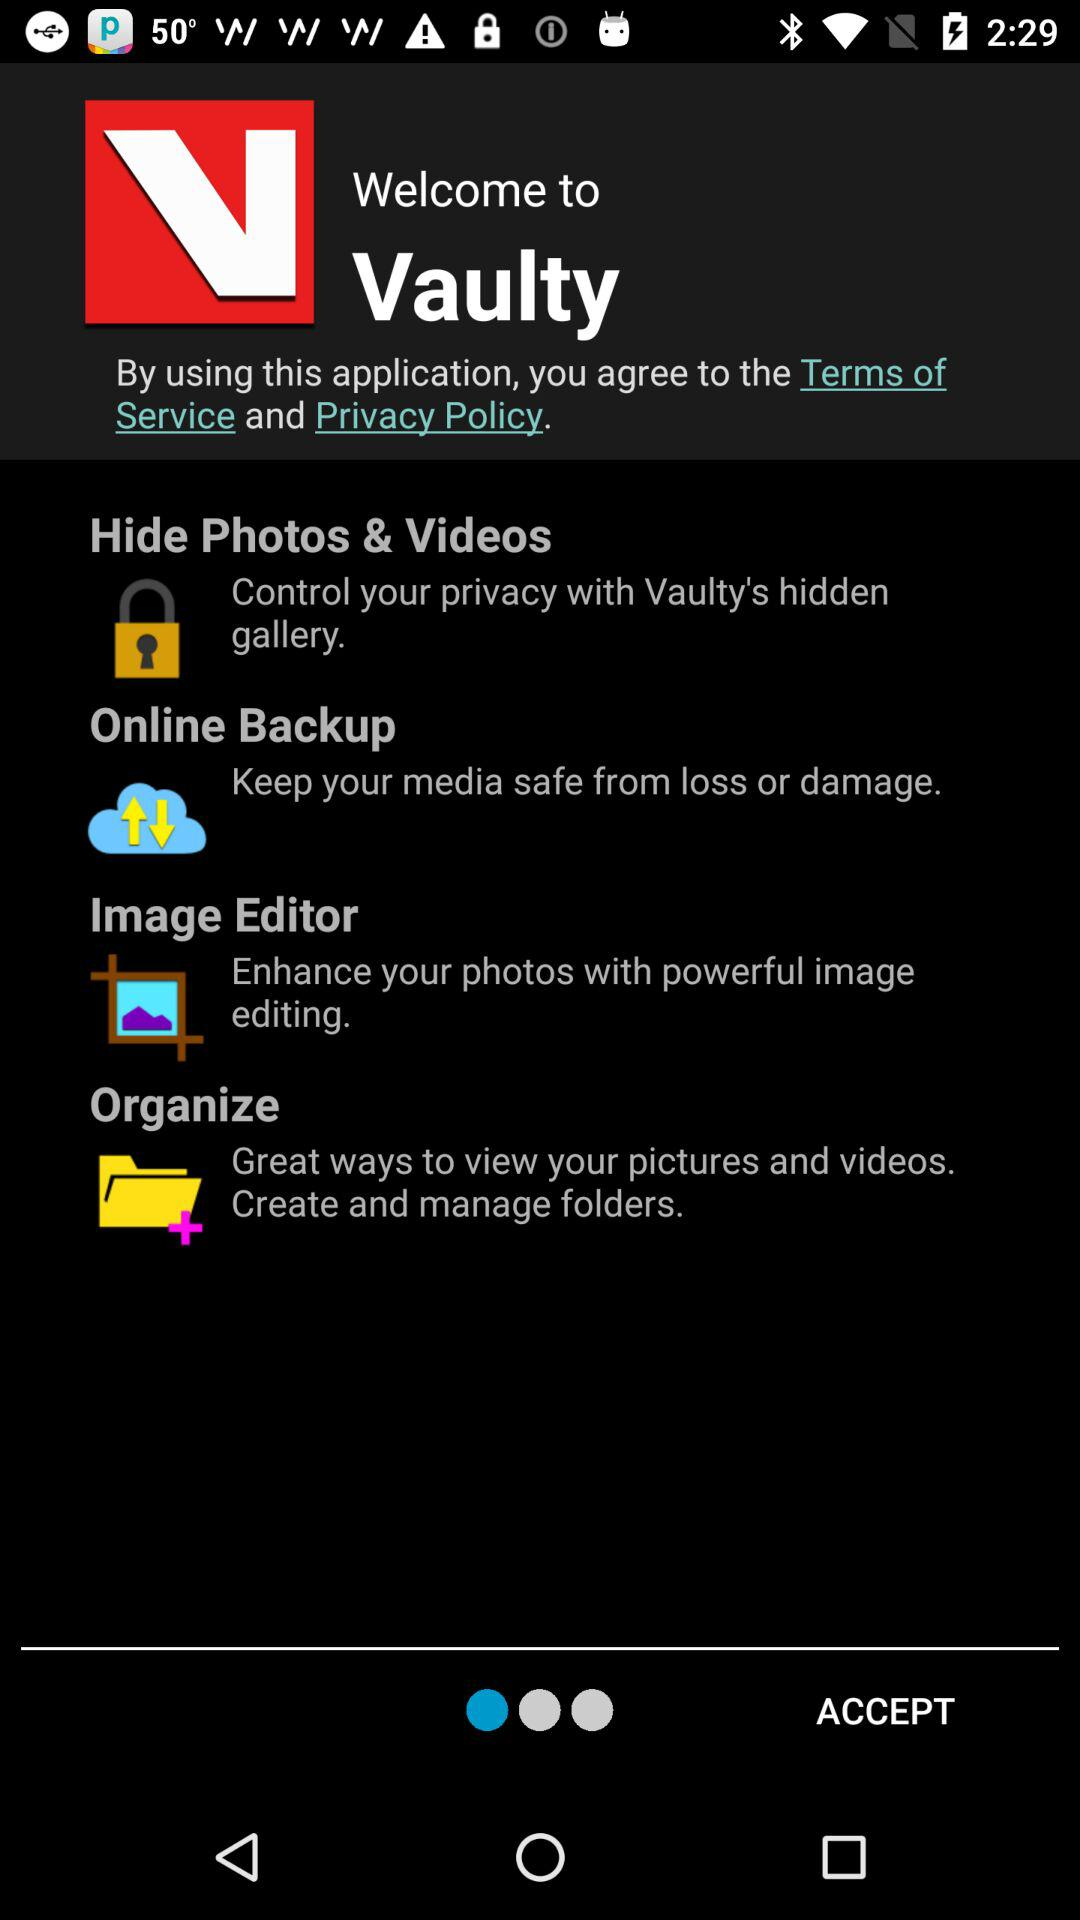What is the name of the application? The name of the application is "Vaulty". 